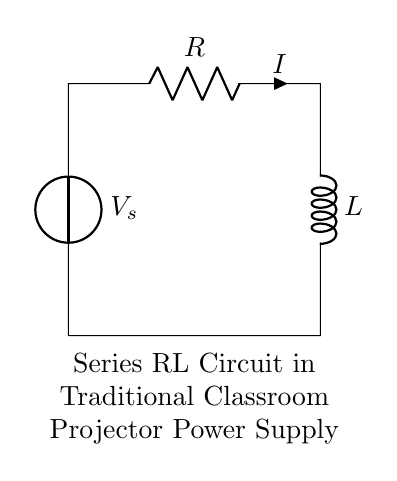What is the source voltage in the circuit? The voltage source is labeled as \(V_s\), indicating the input voltage in the circuit.
Answer: V_s What component limits the current in this circuit? The resistor \(R\) is present in the circuit and serves to limit the current flow by resisting the electric charge movement.
Answer: R What type of circuit is represented? The circuit consists of a resistor and inductor connected in series, which classifies it as a series RL circuit.
Answer: series RL circuit How many components are in the circuit? The circuit contains two primary components: a resistor and an inductor, making a total of two components.
Answer: 2 What is the significance of the inductor in the power supply? The inductor \(L\) helps to manage current flow and smooth out fluctuations, ensuring a more stable voltage supply to the projector.
Answer: stable voltage What happens to the current over time in a series RL circuit when the voltage is suddenly applied? The current increases gradually rather than instantaneously due to the inductor opposing changes in current flow initially.
Answer: gradual increase How does the resistor and inductor arrangement affect the overall impedance? The total impedance in a series RL circuit is the vector sum of the resistance \(R\) and the inductive reactance \(X_L\), where \(X_L\) depends on the frequency of the alternating current.
Answer: R + jX_L 